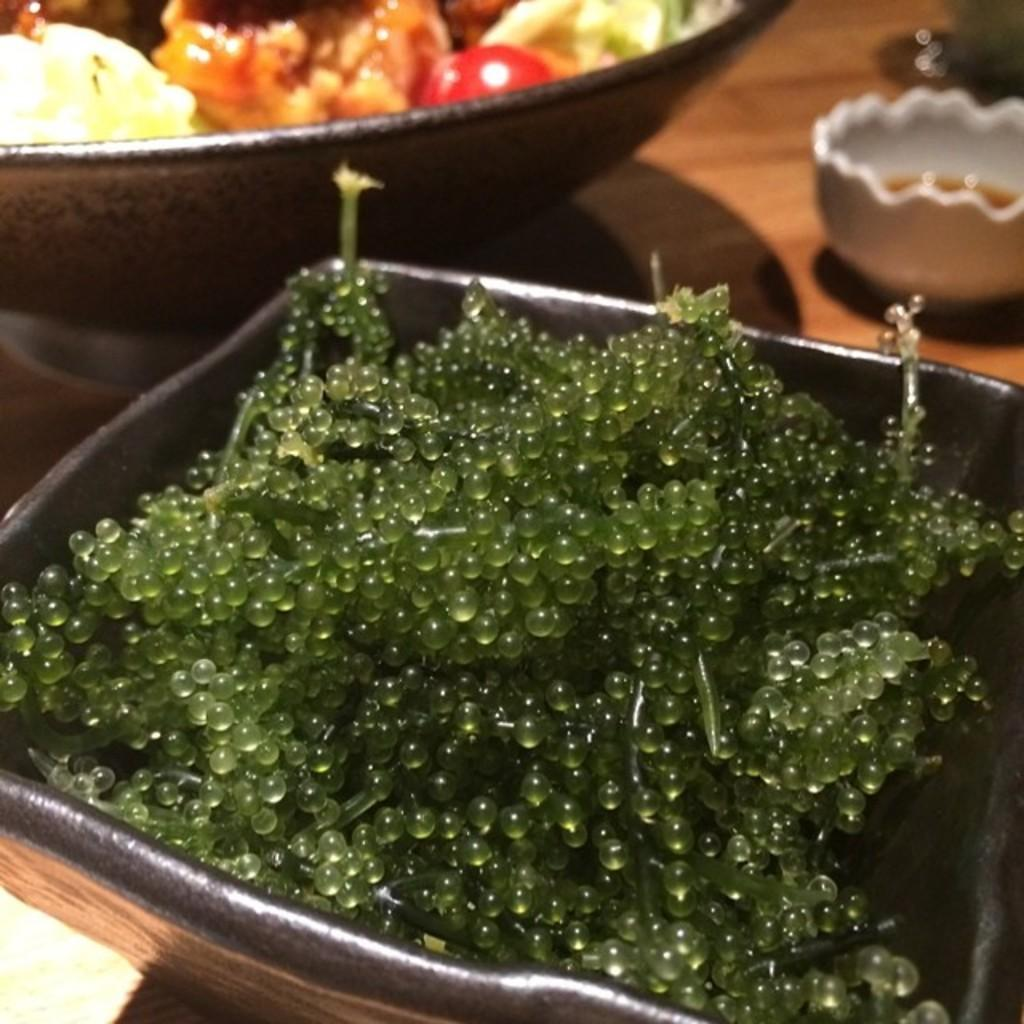What is the main piece of furniture in the image? There is a table in the image. What is placed on the table? There are bowls with different dishes on the table. What can be seen in the foreground of the image? There are gelatin balls in the foreground of the image. How many cactus plants are visible in the image? There are no cactus plants visible in the image. What causes the gelatin balls to burst in the image? The gelatin balls do not burst in the image; they are stationary. 